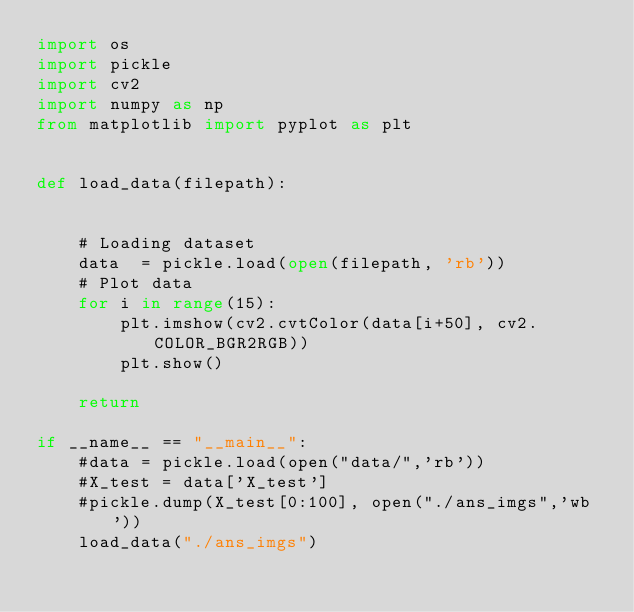Convert code to text. <code><loc_0><loc_0><loc_500><loc_500><_Python_>import os
import pickle
import cv2
import numpy as np
from matplotlib import pyplot as plt


def load_data(filepath):
    
    
    # Loading dataset
    data  = pickle.load(open(filepath, 'rb'))
    # Plot data
    for i in range(15):
        plt.imshow(cv2.cvtColor(data[i+50], cv2.COLOR_BGR2RGB))
        plt.show()
    
    return 

if __name__ == "__main__":
    #data = pickle.load(open("data/",'rb'))
    #X_test = data['X_test']
    #pickle.dump(X_test[0:100], open("./ans_imgs",'wb'))
    load_data("./ans_imgs")
    

</code> 